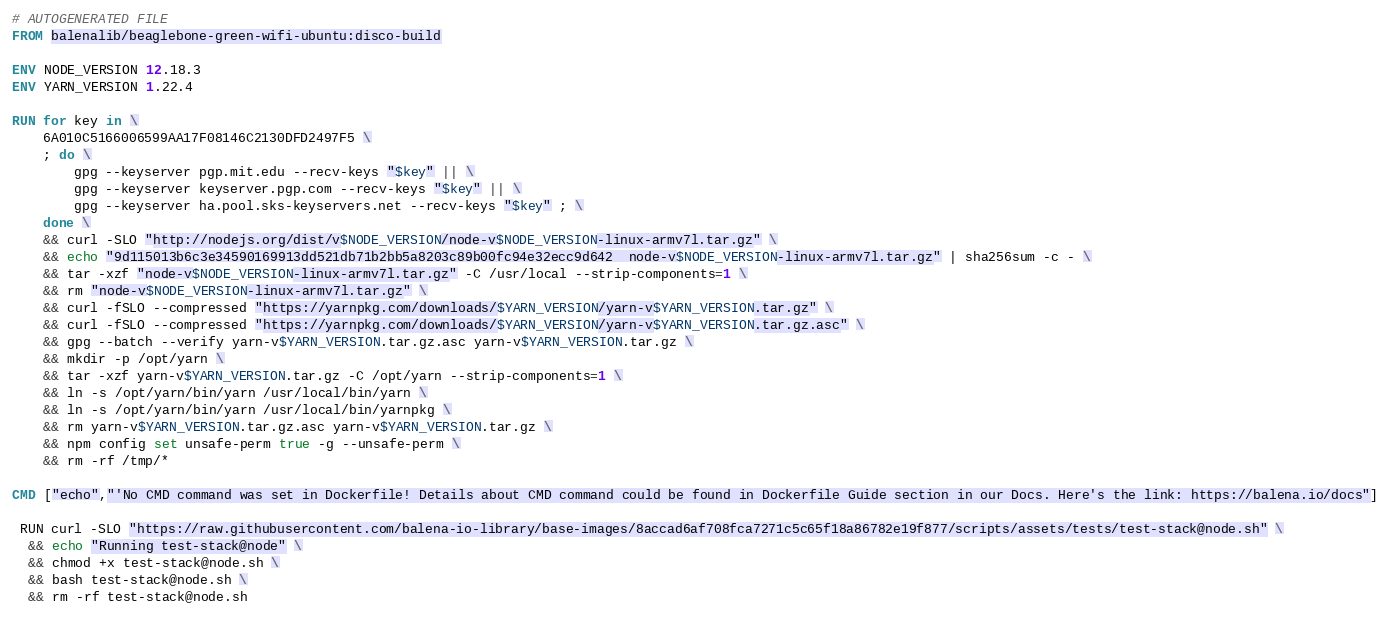Convert code to text. <code><loc_0><loc_0><loc_500><loc_500><_Dockerfile_># AUTOGENERATED FILE
FROM balenalib/beaglebone-green-wifi-ubuntu:disco-build

ENV NODE_VERSION 12.18.3
ENV YARN_VERSION 1.22.4

RUN for key in \
	6A010C5166006599AA17F08146C2130DFD2497F5 \
	; do \
		gpg --keyserver pgp.mit.edu --recv-keys "$key" || \
		gpg --keyserver keyserver.pgp.com --recv-keys "$key" || \
		gpg --keyserver ha.pool.sks-keyservers.net --recv-keys "$key" ; \
	done \
	&& curl -SLO "http://nodejs.org/dist/v$NODE_VERSION/node-v$NODE_VERSION-linux-armv7l.tar.gz" \
	&& echo "9d115013b6c3e34590169913dd521db71b2bb5a8203c89b00fc94e32ecc9d642  node-v$NODE_VERSION-linux-armv7l.tar.gz" | sha256sum -c - \
	&& tar -xzf "node-v$NODE_VERSION-linux-armv7l.tar.gz" -C /usr/local --strip-components=1 \
	&& rm "node-v$NODE_VERSION-linux-armv7l.tar.gz" \
	&& curl -fSLO --compressed "https://yarnpkg.com/downloads/$YARN_VERSION/yarn-v$YARN_VERSION.tar.gz" \
	&& curl -fSLO --compressed "https://yarnpkg.com/downloads/$YARN_VERSION/yarn-v$YARN_VERSION.tar.gz.asc" \
	&& gpg --batch --verify yarn-v$YARN_VERSION.tar.gz.asc yarn-v$YARN_VERSION.tar.gz \
	&& mkdir -p /opt/yarn \
	&& tar -xzf yarn-v$YARN_VERSION.tar.gz -C /opt/yarn --strip-components=1 \
	&& ln -s /opt/yarn/bin/yarn /usr/local/bin/yarn \
	&& ln -s /opt/yarn/bin/yarn /usr/local/bin/yarnpkg \
	&& rm yarn-v$YARN_VERSION.tar.gz.asc yarn-v$YARN_VERSION.tar.gz \
	&& npm config set unsafe-perm true -g --unsafe-perm \
	&& rm -rf /tmp/*

CMD ["echo","'No CMD command was set in Dockerfile! Details about CMD command could be found in Dockerfile Guide section in our Docs. Here's the link: https://balena.io/docs"]

 RUN curl -SLO "https://raw.githubusercontent.com/balena-io-library/base-images/8accad6af708fca7271c5c65f18a86782e19f877/scripts/assets/tests/test-stack@node.sh" \
  && echo "Running test-stack@node" \
  && chmod +x test-stack@node.sh \
  && bash test-stack@node.sh \
  && rm -rf test-stack@node.sh 
</code> 